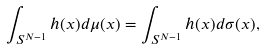Convert formula to latex. <formula><loc_0><loc_0><loc_500><loc_500>\int _ { S ^ { N - 1 } } h ( x ) d \mu ( x ) = \int _ { S ^ { N - 1 } } h ( x ) d \sigma ( x ) ,</formula> 